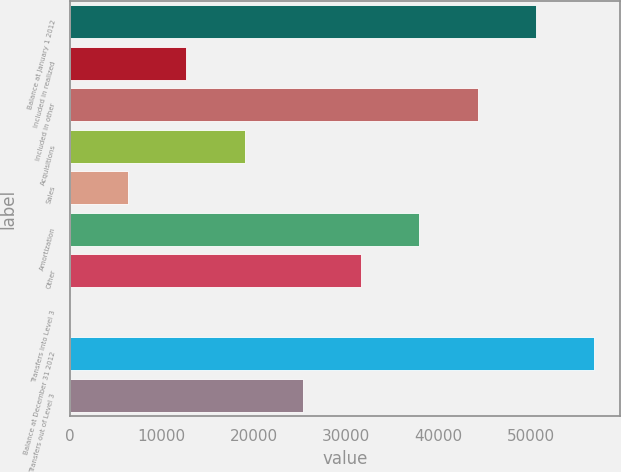Convert chart to OTSL. <chart><loc_0><loc_0><loc_500><loc_500><bar_chart><fcel>Balance at January 1 2012<fcel>Included in realized<fcel>Included in other<fcel>Acquisitions<fcel>Sales<fcel>Amortization<fcel>Other<fcel>Transfers into Level 3<fcel>Balance at December 31 2012<fcel>Transfers out of Level 3<nl><fcel>50585.7<fcel>12646.6<fcel>44262.5<fcel>18969.8<fcel>6323.46<fcel>37939.3<fcel>31616.1<fcel>0.29<fcel>56908.8<fcel>25293<nl></chart> 